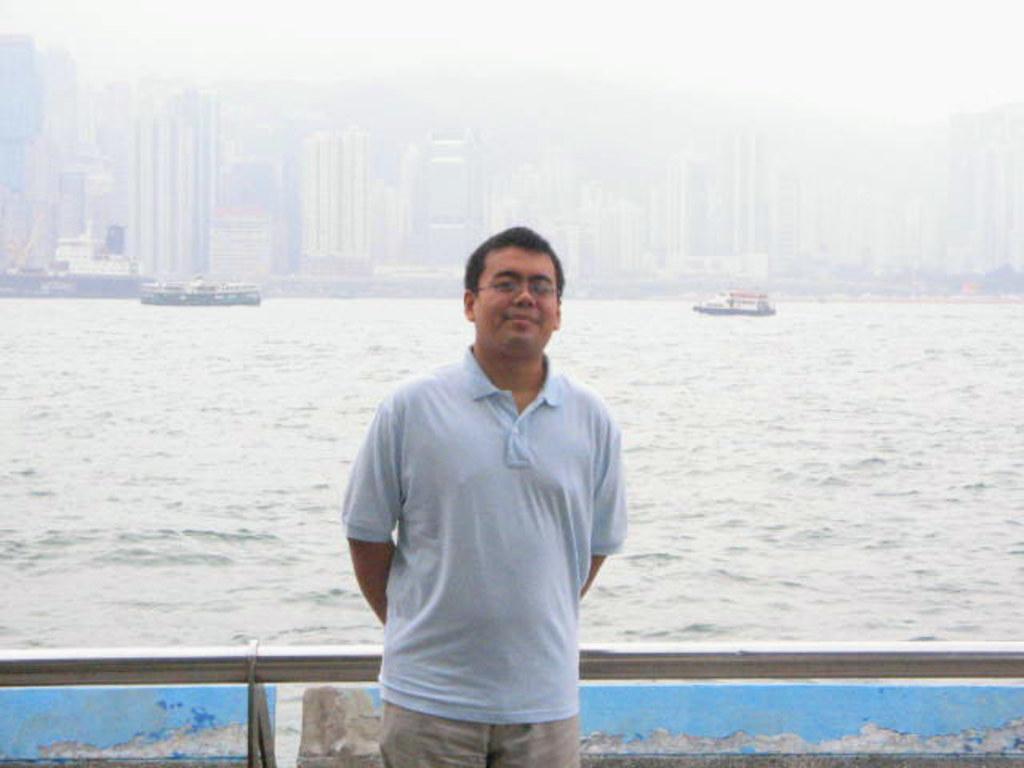Could you give a brief overview of what you see in this image? In this picture there is a man standing and smiling. At the back there is a railing and there are buildings. There are boats and there is a ship on the water. At the top there is sky. At the bottom there is water. 